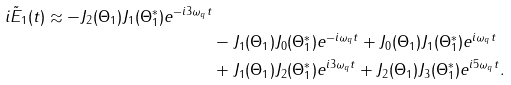Convert formula to latex. <formula><loc_0><loc_0><loc_500><loc_500>{ i \tilde { E } _ { 1 } ( t ) \approx - J _ { 2 } ( \Theta _ { 1 } ) J _ { 1 } ( \Theta _ { 1 } ^ { * } ) e ^ { - i 3 \omega _ { q } t } } \\ & - J _ { 1 } ( \Theta _ { 1 } ) J _ { 0 } ( \Theta _ { 1 } ^ { * } ) e ^ { - i \omega _ { q } t } + J _ { 0 } ( \Theta _ { 1 } ) J _ { 1 } ( \Theta _ { 1 } ^ { * } ) e ^ { i \omega _ { q } t } \\ & + J _ { 1 } ( \Theta _ { 1 } ) J _ { 2 } ( \Theta _ { 1 } ^ { * } ) e ^ { i 3 \omega _ { q } t } + J _ { 2 } ( \Theta _ { 1 } ) J _ { 3 } ( \Theta _ { 1 } ^ { * } ) e ^ { i 5 \omega _ { q } t } .</formula> 